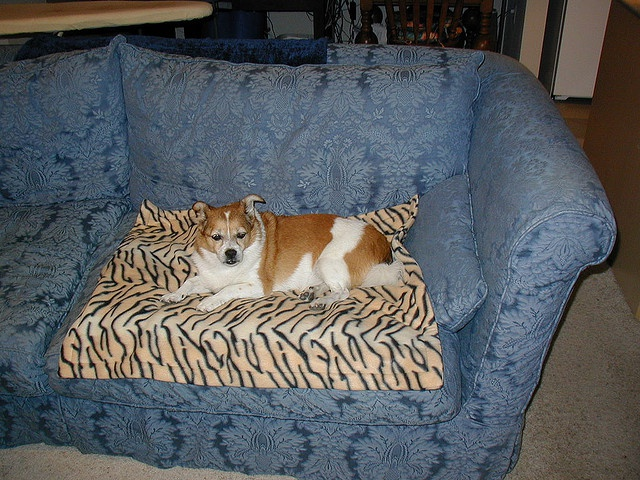Describe the objects in this image and their specific colors. I can see couch in gray, black, and blue tones, dog in black, lightgray, darkgray, brown, and tan tones, and chair in black, maroon, gray, and purple tones in this image. 